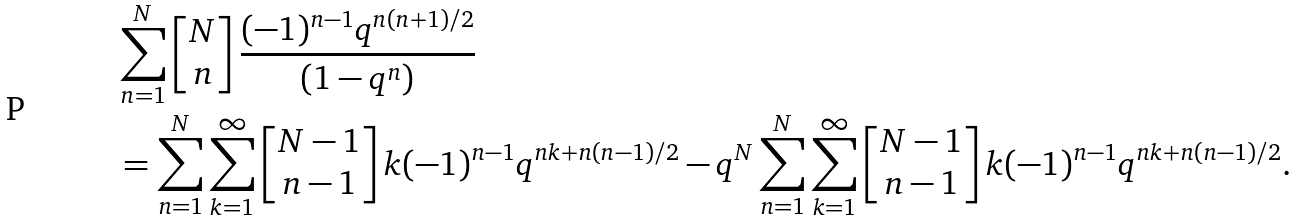Convert formula to latex. <formula><loc_0><loc_0><loc_500><loc_500>& \sum _ { n = 1 } ^ { N } \left [ \begin{matrix} N \\ n \end{matrix} \right ] \frac { ( - 1 ) ^ { n - 1 } q ^ { n ( n + 1 ) / 2 } } { ( 1 - q ^ { n } ) } \\ & = \sum _ { n = 1 } ^ { N } \sum _ { k = 1 } ^ { \infty } \left [ \begin{matrix} N - 1 \\ n - 1 \end{matrix} \right ] k ( - 1 ) ^ { n - 1 } q ^ { n k + n ( n - 1 ) / 2 } - q ^ { N } \sum _ { n = 1 } ^ { N } \sum _ { k = 1 } ^ { \infty } \left [ \begin{matrix} N - 1 \\ n - 1 \end{matrix} \right ] k ( - 1 ) ^ { n - 1 } q ^ { n k + n ( n - 1 ) / 2 } .</formula> 